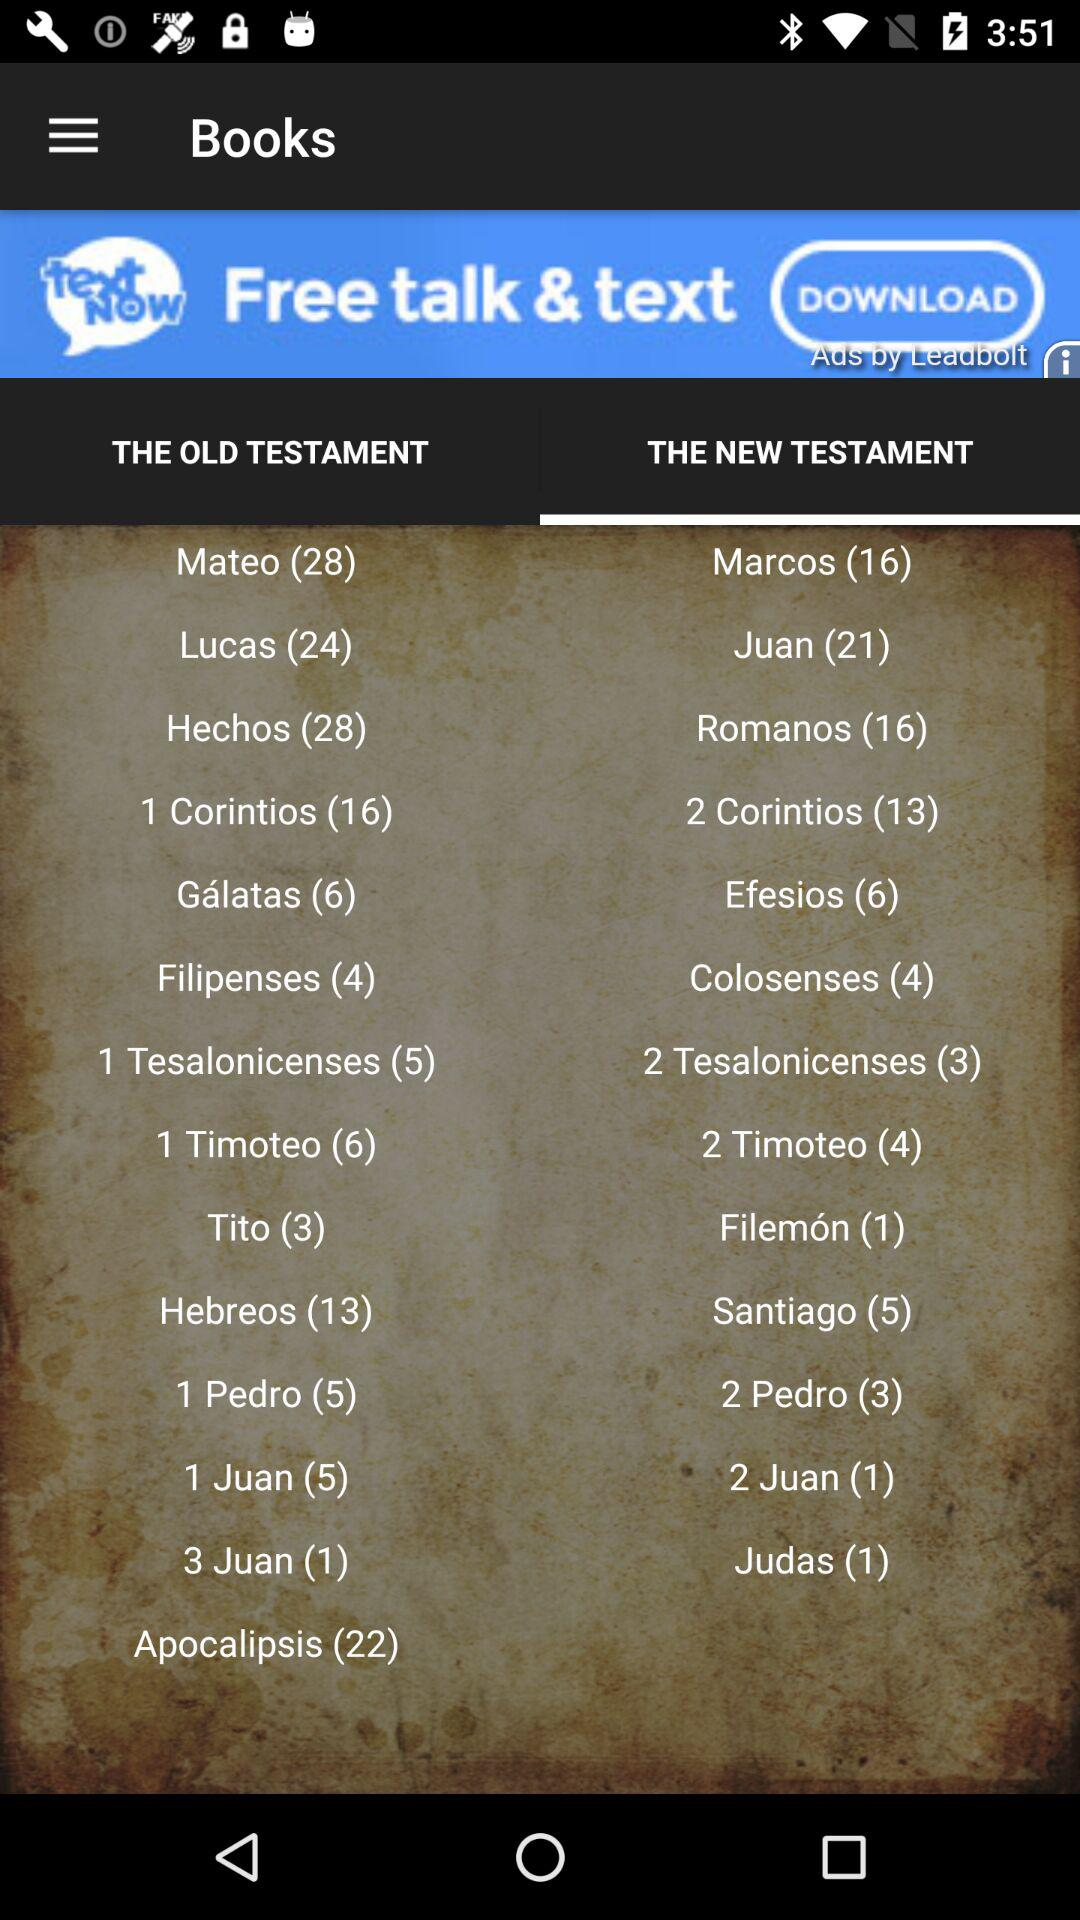How many books are in "Mateo"? There are 28 books. 